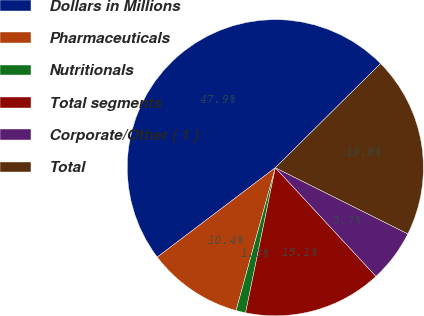Convert chart. <chart><loc_0><loc_0><loc_500><loc_500><pie_chart><fcel>Dollars in Millions<fcel>Pharmaceuticals<fcel>Nutritionals<fcel>Total segments<fcel>Corporate/Other ( 1 )<fcel>Total<nl><fcel>47.9%<fcel>10.42%<fcel>1.05%<fcel>15.11%<fcel>5.74%<fcel>19.79%<nl></chart> 